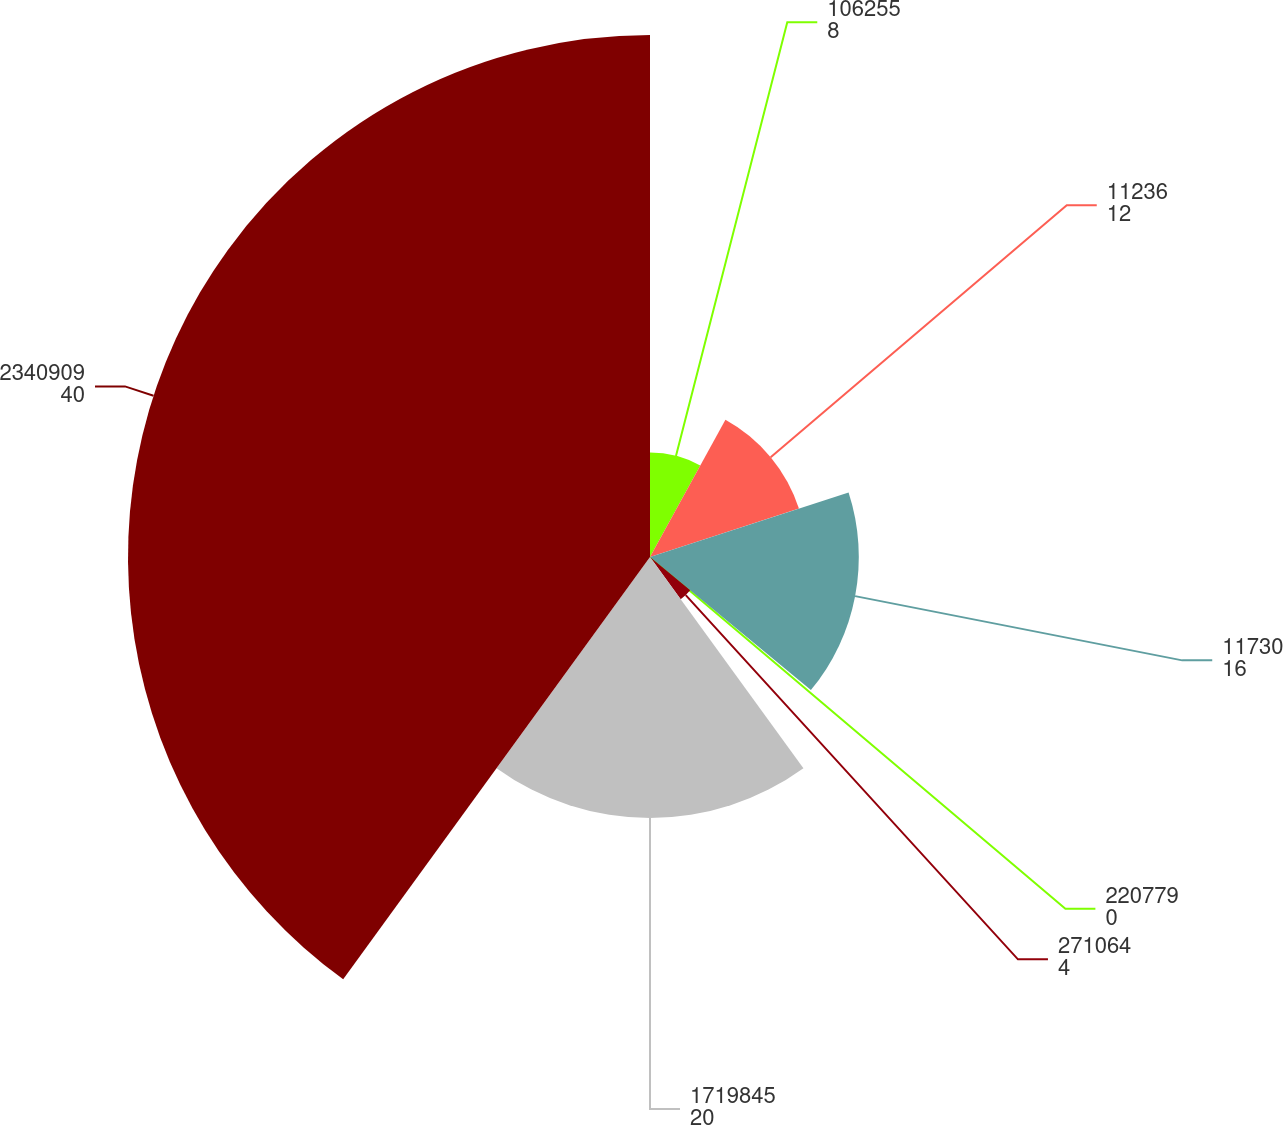Convert chart to OTSL. <chart><loc_0><loc_0><loc_500><loc_500><pie_chart><fcel>106255<fcel>11236<fcel>11730<fcel>220779<fcel>271064<fcel>1719845<fcel>2340909<nl><fcel>8.0%<fcel>12.0%<fcel>16.0%<fcel>0.0%<fcel>4.0%<fcel>20.0%<fcel>40.0%<nl></chart> 